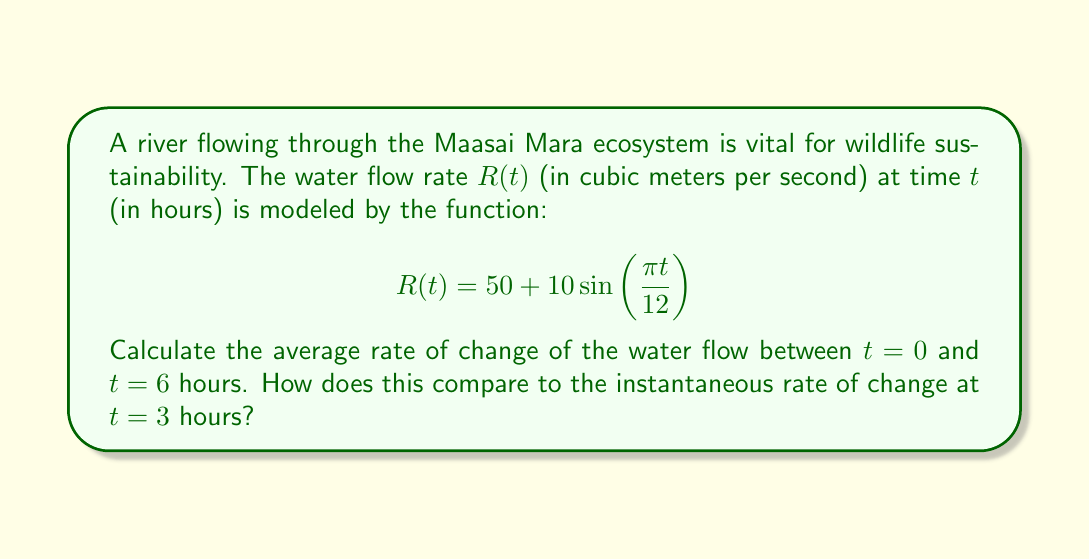Solve this math problem. To solve this problem, we need to follow these steps:

1. Calculate the average rate of change between $t = 0$ and $t = 6$ hours:
   The average rate of change is given by the formula:
   $$\text{Average rate of change} = \frac{R(6) - R(0)}{6 - 0}$$

   First, let's calculate $R(0)$ and $R(6)$:
   $$R(0) = 50 + 10\sin(\frac{\pi \cdot 0}{12}) = 50 + 0 = 50$$
   $$R(6) = 50 + 10\sin(\frac{\pi \cdot 6}{12}) = 50 + 10\sin(\frac{\pi}{2}) = 50 + 10 = 60$$

   Now, we can calculate the average rate of change:
   $$\text{Average rate of change} = \frac{60 - 50}{6 - 0} = \frac{10}{6} \approx 1.67 \text{ m}^3\text{/s/hour}$$

2. Calculate the instantaneous rate of change at $t = 3$ hours:
   The instantaneous rate of change is given by the derivative of $R(t)$ at $t = 3$:
   $$R'(t) = 10 \cdot \frac{\pi}{12} \cos(\frac{\pi t}{12})$$
   $$R'(3) = 10 \cdot \frac{\pi}{12} \cos(\frac{\pi \cdot 3}{12}) = \frac{5\pi}{6} \cos(\frac{\pi}{4}) \approx 2.31 \text{ m}^3\text{/s/hour}$$

3. Compare the two rates:
   The instantaneous rate of change at $t = 3$ hours (approximately 2.31 m³/s/hour) is higher than the average rate of change between $t = 0$ and $t = 6$ hours (approximately 1.67 m³/s/hour). This indicates that the water flow is increasing more rapidly at the 3-hour mark compared to the average increase over the 6-hour period.
Answer: The average rate of change between $t = 0$ and $t = 6$ hours is approximately 1.67 m³/s/hour. The instantaneous rate of change at $t = 3$ hours is approximately 2.31 m³/s/hour. The instantaneous rate at $t = 3$ is higher than the average rate over the 6-hour period. 